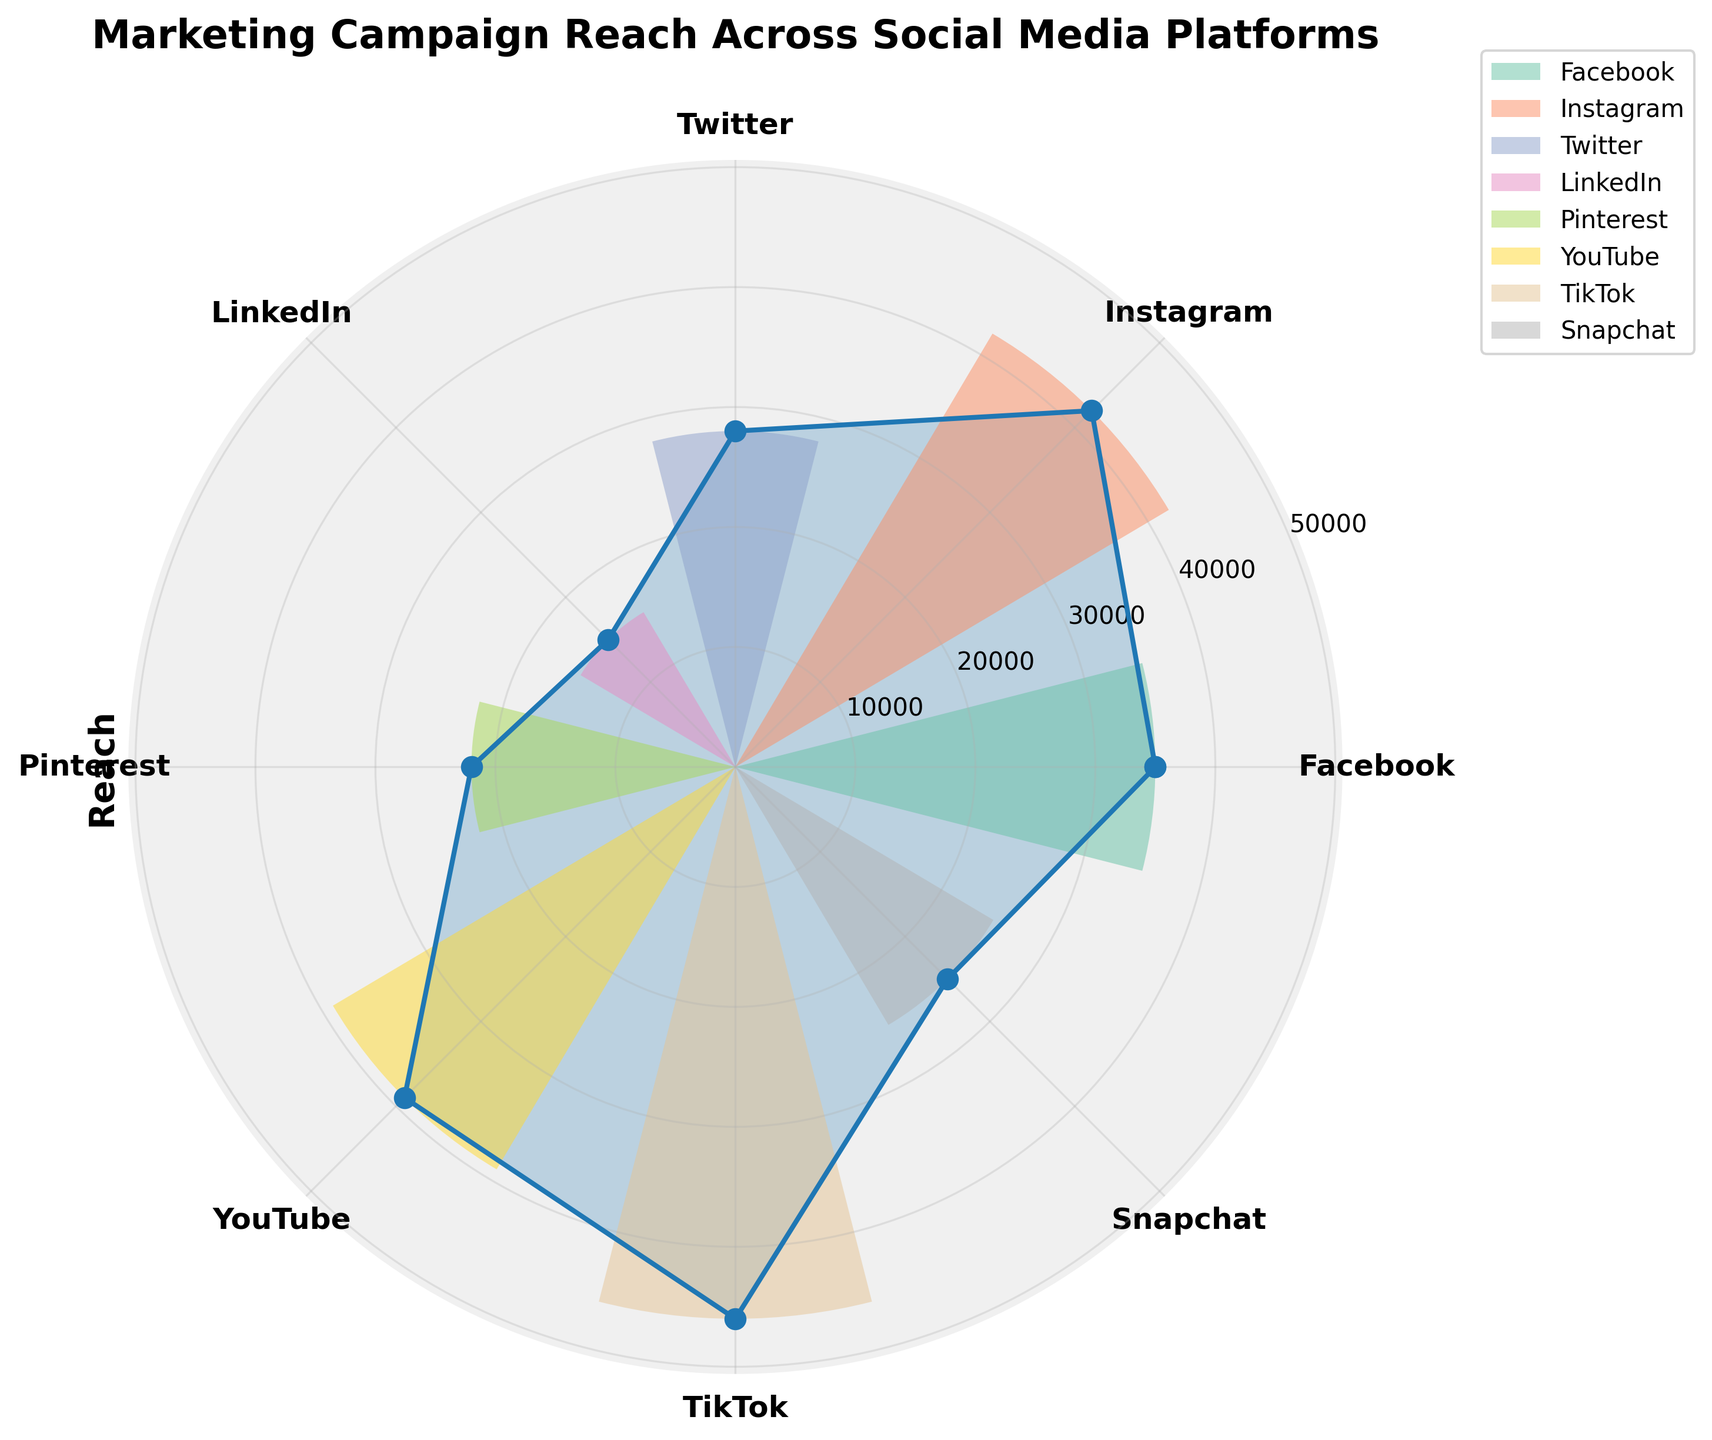What's the title of the chart? The title is usually displayed at the top of the chart. In this case, it is clearly shown there.
Answer: Marketing Campaign Reach Across Social Media Platforms Which social media platform has the highest reach? By observing the lengths of the bars in the polar area chart, the longest represents the platform with the highest reach.
Answer: TikTok What is the reach of Instagram? Look at the labeled Instagram section in the polar area chart and read the corresponding value.
Answer: 42,000 How does YouTube's reach compare to Pinterest's reach? Identify the bars for YouTube and Pinterest. YouTube has a longer bar, indicating a higher reach.
Answer: YouTube has a higher reach What is the cumulative reach of Facebook, Twitter, and LinkedIn? Add the reach values for Facebook (35,000), Twitter (28,000), and LinkedIn (15,000). 35,000 + 28,000 + 15,000 = 78,000
Answer: 78,000 Which social media platform has the smallest reach? Find the shortest bar in the polar area chart, which represents the platform with the smallest reach.
Answer: LinkedIn How many social media platforms have a reach greater than 30,000? Count the number of platforms whose bars extend beyond the 30,000 mark.
Answer: 5 platforms What is the difference in reach between TikTok and Snapchat? Subtract the reach of Snapchat (25,000) from the reach of TikTok (46,000). 46,000 - 25,000 = 21,000
Answer: 21,000 What's the average reach across all platforms displayed in the chart? Sum the reach values of all platforms and divide by the number of platforms. (35,000 + 42,000 + 28,000 + 15,000 + 22,000 + 39,000 + 46,000 + 25,000) / 8 = 31,500
Answer: 31,500 If you combined the reach of Instagram and YouTube, how would it compare to TikTok? Add the reach values for Instagram (42,000) and YouTube (39,000) to get 81,000. Compare this with TikTok's reach (46,000). 81,000 > 46,000
Answer: Combined reach is greater 